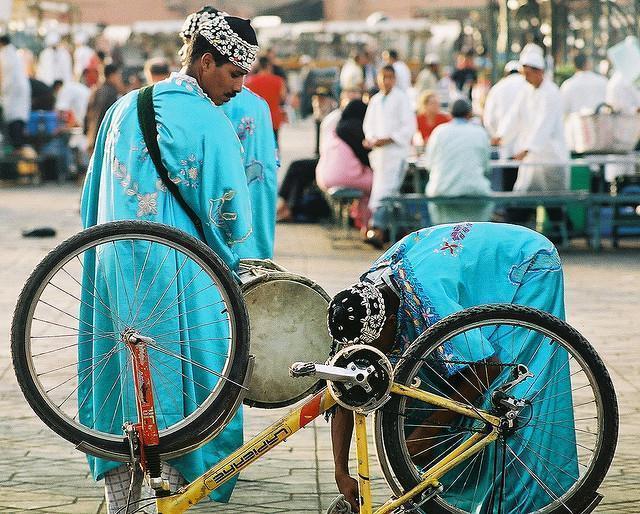What mode of transportation is upside-down?
Select the correct answer and articulate reasoning with the following format: 'Answer: answer
Rationale: rationale.'
Options: Bicycle, skateboard, scooter, moped. Answer: bicycle.
Rationale: Besides buses in the background the only other visible transportation mode is in the foreground.  with wheels facing the sky, it is apparent that the bicycle is upside down. 